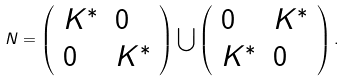Convert formula to latex. <formula><loc_0><loc_0><loc_500><loc_500>N = \left ( \begin{array} { l l } K ^ { * } & 0 \\ 0 & K ^ { * } \end{array} \right ) \bigcup \left ( \begin{array} { l l } 0 & K ^ { * } \\ K ^ { * } & 0 \end{array} \right ) .</formula> 